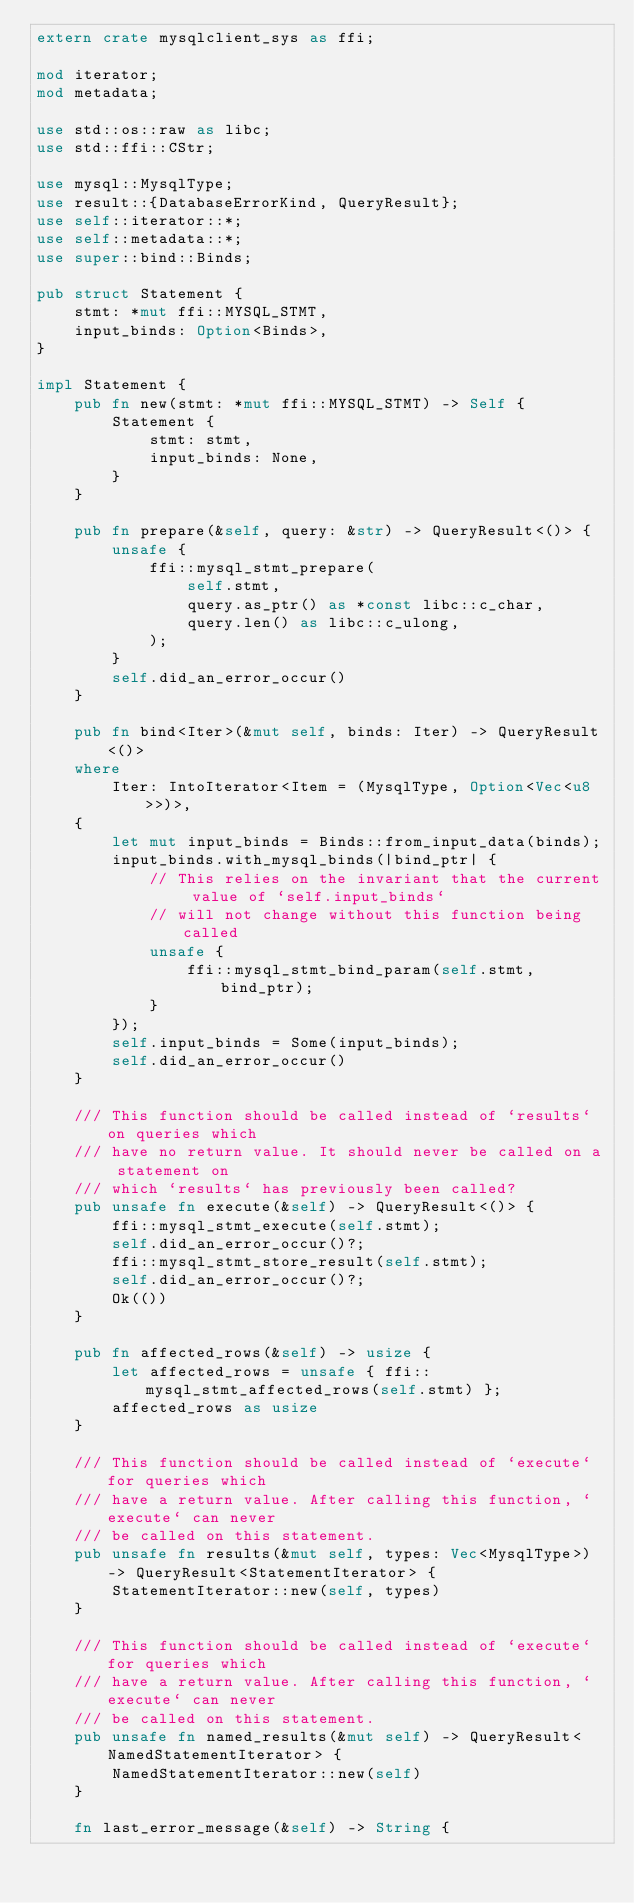Convert code to text. <code><loc_0><loc_0><loc_500><loc_500><_Rust_>extern crate mysqlclient_sys as ffi;

mod iterator;
mod metadata;

use std::os::raw as libc;
use std::ffi::CStr;

use mysql::MysqlType;
use result::{DatabaseErrorKind, QueryResult};
use self::iterator::*;
use self::metadata::*;
use super::bind::Binds;

pub struct Statement {
    stmt: *mut ffi::MYSQL_STMT,
    input_binds: Option<Binds>,
}

impl Statement {
    pub fn new(stmt: *mut ffi::MYSQL_STMT) -> Self {
        Statement {
            stmt: stmt,
            input_binds: None,
        }
    }

    pub fn prepare(&self, query: &str) -> QueryResult<()> {
        unsafe {
            ffi::mysql_stmt_prepare(
                self.stmt,
                query.as_ptr() as *const libc::c_char,
                query.len() as libc::c_ulong,
            );
        }
        self.did_an_error_occur()
    }

    pub fn bind<Iter>(&mut self, binds: Iter) -> QueryResult<()>
    where
        Iter: IntoIterator<Item = (MysqlType, Option<Vec<u8>>)>,
    {
        let mut input_binds = Binds::from_input_data(binds);
        input_binds.with_mysql_binds(|bind_ptr| {
            // This relies on the invariant that the current value of `self.input_binds`
            // will not change without this function being called
            unsafe {
                ffi::mysql_stmt_bind_param(self.stmt, bind_ptr);
            }
        });
        self.input_binds = Some(input_binds);
        self.did_an_error_occur()
    }

    /// This function should be called instead of `results` on queries which
    /// have no return value. It should never be called on a statement on
    /// which `results` has previously been called?
    pub unsafe fn execute(&self) -> QueryResult<()> {
        ffi::mysql_stmt_execute(self.stmt);
        self.did_an_error_occur()?;
        ffi::mysql_stmt_store_result(self.stmt);
        self.did_an_error_occur()?;
        Ok(())
    }

    pub fn affected_rows(&self) -> usize {
        let affected_rows = unsafe { ffi::mysql_stmt_affected_rows(self.stmt) };
        affected_rows as usize
    }

    /// This function should be called instead of `execute` for queries which
    /// have a return value. After calling this function, `execute` can never
    /// be called on this statement.
    pub unsafe fn results(&mut self, types: Vec<MysqlType>) -> QueryResult<StatementIterator> {
        StatementIterator::new(self, types)
    }

    /// This function should be called instead of `execute` for queries which
    /// have a return value. After calling this function, `execute` can never
    /// be called on this statement.
    pub unsafe fn named_results(&mut self) -> QueryResult<NamedStatementIterator> {
        NamedStatementIterator::new(self)
    }

    fn last_error_message(&self) -> String {</code> 